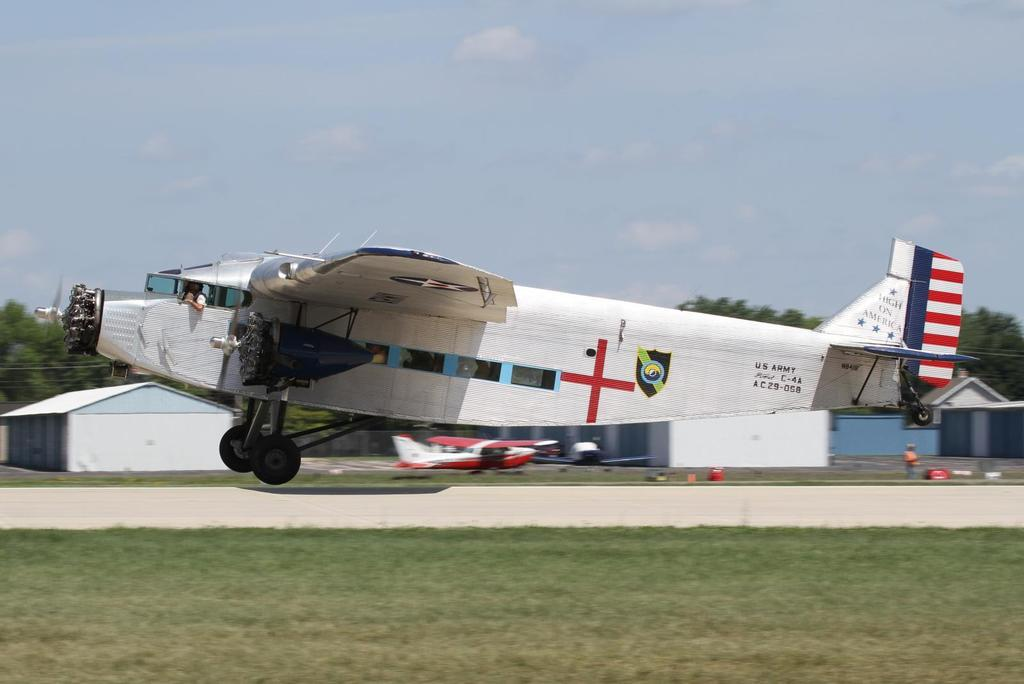What is the main subject of the image? The main subject of the image is airplanes. Can you describe the person in the image? There is a person in the image, but no specific details about them are provided. What can be seen on the ground in the image? There are objects on the ground in the image, but no specific details about them are provided. What is visible in the background of the image? In the background of the image, there are buildings, trees, and the sky. What is the condition of the sky in the image? The sky is visible in the background of the image, and clouds are present. What type of note is the person holding in the image? There is no note present in the image; only airplanes, a person, objects on the ground, buildings, trees, the sky, and clouds are mentioned. 